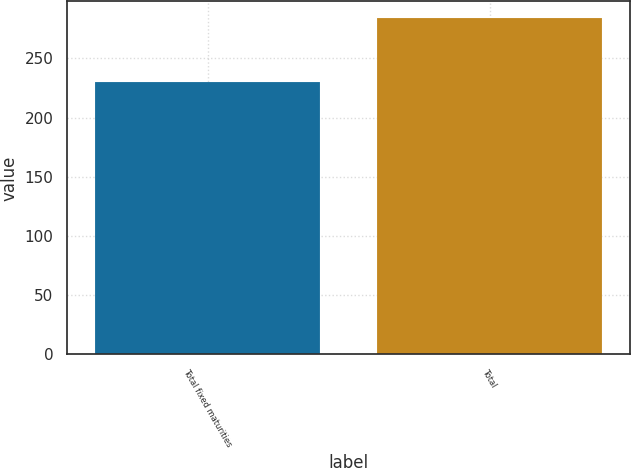Convert chart to OTSL. <chart><loc_0><loc_0><loc_500><loc_500><bar_chart><fcel>Total fixed maturities<fcel>Total<nl><fcel>230<fcel>284<nl></chart> 